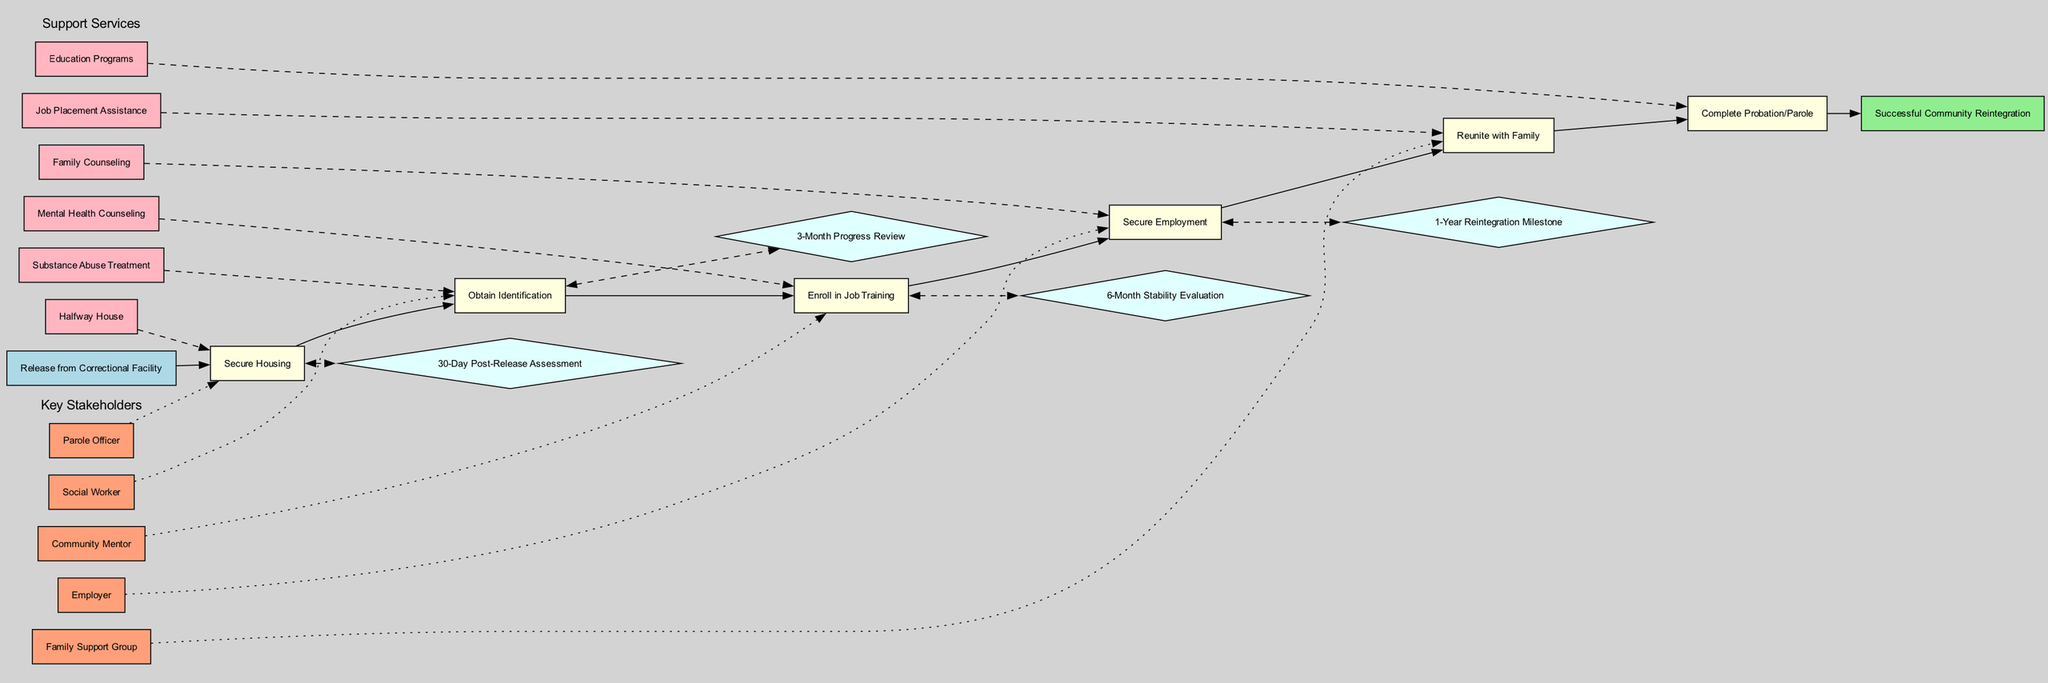What is the starting point of the pathway? The starting point is explicitly labeled as "Release from Correctional Facility" in the diagram.
Answer: Release from Correctional Facility How many milestones are in the pathway? By counting the nodes labeled as milestones in the diagram, there are a total of six milestones present.
Answer: 6 What is the last milestone before the endpoint? The last milestone before reaching the endpoint is directly connected to the endpoint node and is labeled as "Complete Probation/Parole".
Answer: Complete Probation/Parole Which support service is linked to the first milestone? In the diagram, the first milestone ("Secure Housing") is connected to the support service, which is "Halfway House" as indicated by the dashed line.
Answer: Halfway House Name one key stakeholder associated with "Secure Employment". The stakeholder connected to "Secure Employment" is "Employer", which can be seen in the relationships drawn in the diagram.
Answer: Employer What is the second checkpoint in the pathway? The checkpoints are represented by diamond-shaped nodes, and the second one is labeled "3-Month Progress Review".
Answer: 3-Month Progress Review Which milestone has the most support services connected to it? By analyzing the connections, "Enroll in Job Training" has multiple support services linked to it, indicating it interacts with various support services in the diagram.
Answer: Enroll in Job Training How many key stakeholders are represented in the diagram? There are a total of five nodes labeled as key stakeholders as seen in the diagram.
Answer: 5 What type of nodes are the checkpoints? The checkpoints are visually represented as diamond-shaped nodes in the diagram, distinguishing them from other types of nodes.
Answer: Diamond-shaped 